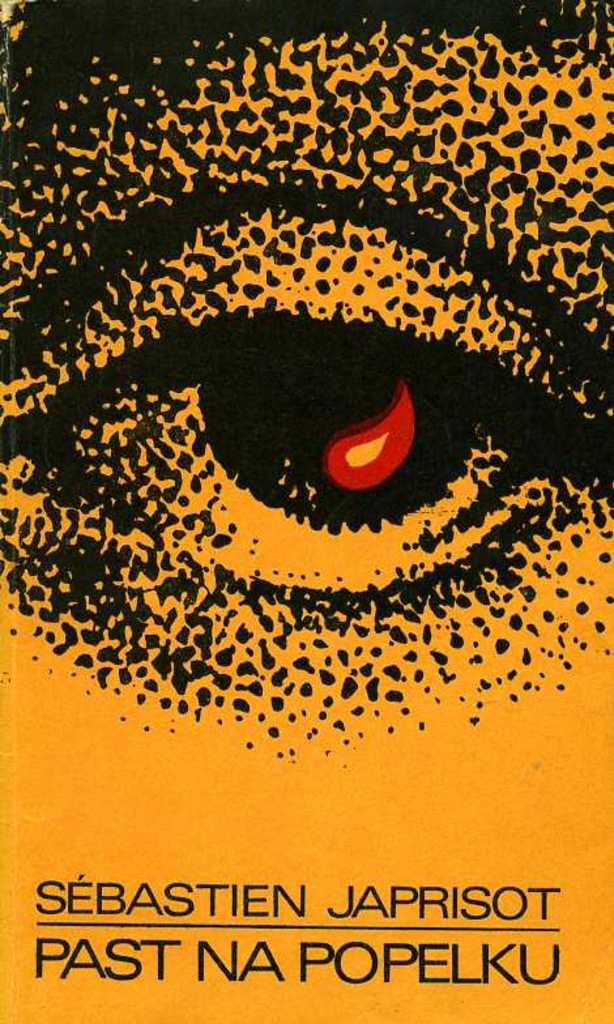Provide a one-sentence caption for the provided image. Cover showing an eye and the name Sebastien Japrisot. 